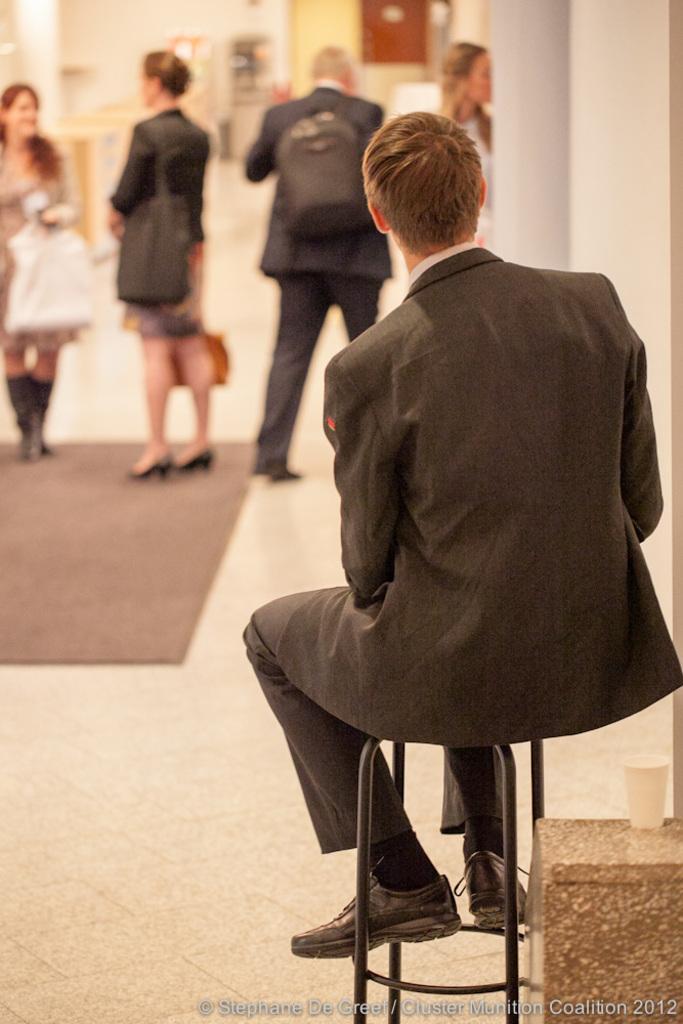Please provide a concise description of this image. On the right side of this image there is a man sitting on a stool facing towards the back side. In the background there are few people holding bags and standing on the floor. On the floor I can see a mat. In the background there is a wall and few objects are placed on the floor. In the bottom right there is a table on which a glass is placed. 